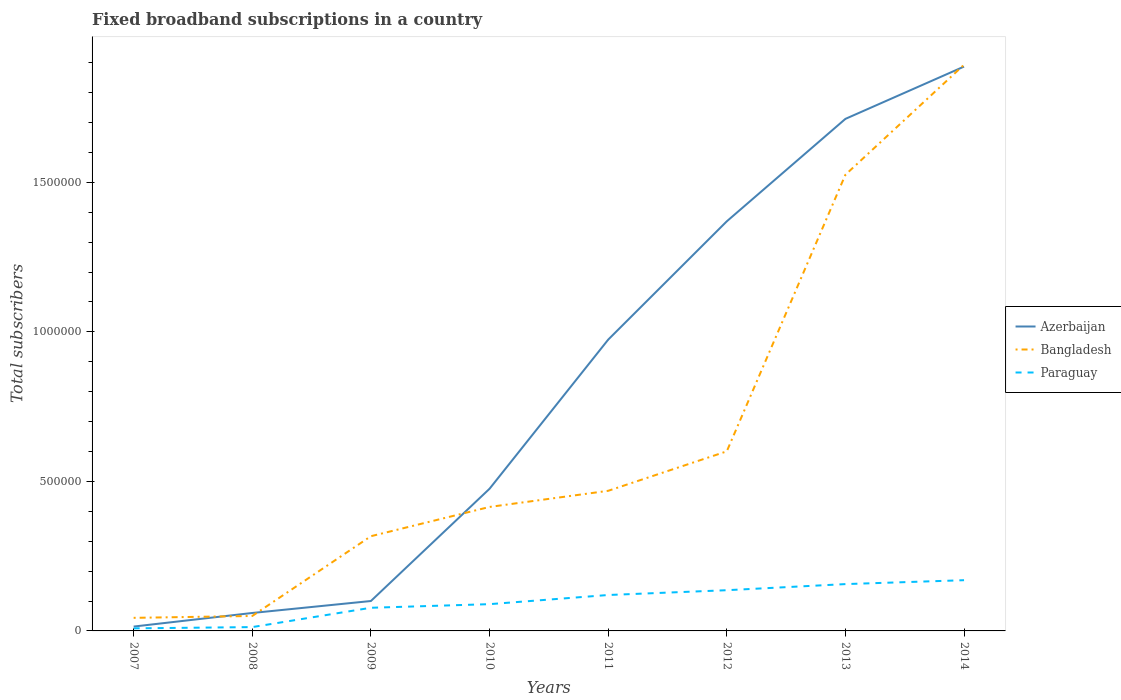How many different coloured lines are there?
Provide a succinct answer. 3. Does the line corresponding to Bangladesh intersect with the line corresponding to Azerbaijan?
Offer a terse response. Yes. Across all years, what is the maximum number of broadband subscriptions in Azerbaijan?
Make the answer very short. 1.46e+04. In which year was the number of broadband subscriptions in Paraguay maximum?
Keep it short and to the point. 2007. What is the total number of broadband subscriptions in Bangladesh in the graph?
Offer a terse response. -1.58e+06. What is the difference between the highest and the second highest number of broadband subscriptions in Azerbaijan?
Your response must be concise. 1.87e+06. What is the difference between the highest and the lowest number of broadband subscriptions in Paraguay?
Make the answer very short. 4. How many lines are there?
Your answer should be very brief. 3. What is the difference between two consecutive major ticks on the Y-axis?
Keep it short and to the point. 5.00e+05. Does the graph contain grids?
Make the answer very short. No. How are the legend labels stacked?
Your answer should be very brief. Vertical. What is the title of the graph?
Your answer should be compact. Fixed broadband subscriptions in a country. Does "Mongolia" appear as one of the legend labels in the graph?
Offer a very short reply. No. What is the label or title of the X-axis?
Your response must be concise. Years. What is the label or title of the Y-axis?
Provide a succinct answer. Total subscribers. What is the Total subscribers in Azerbaijan in 2007?
Offer a terse response. 1.46e+04. What is the Total subscribers of Bangladesh in 2007?
Your response must be concise. 4.37e+04. What is the Total subscribers of Paraguay in 2007?
Ensure brevity in your answer.  8600. What is the Total subscribers of Paraguay in 2008?
Provide a succinct answer. 1.28e+04. What is the Total subscribers of Bangladesh in 2009?
Offer a very short reply. 3.17e+05. What is the Total subscribers in Paraguay in 2009?
Provide a succinct answer. 7.74e+04. What is the Total subscribers of Azerbaijan in 2010?
Your answer should be very brief. 4.75e+05. What is the Total subscribers in Bangladesh in 2010?
Give a very brief answer. 4.15e+05. What is the Total subscribers in Paraguay in 2010?
Give a very brief answer. 8.95e+04. What is the Total subscribers in Azerbaijan in 2011?
Give a very brief answer. 9.74e+05. What is the Total subscribers of Bangladesh in 2011?
Keep it short and to the point. 4.68e+05. What is the Total subscribers in Paraguay in 2011?
Offer a terse response. 1.20e+05. What is the Total subscribers of Azerbaijan in 2012?
Offer a terse response. 1.37e+06. What is the Total subscribers of Bangladesh in 2012?
Make the answer very short. 6.00e+05. What is the Total subscribers in Paraguay in 2012?
Your response must be concise. 1.36e+05. What is the Total subscribers of Azerbaijan in 2013?
Your answer should be compact. 1.71e+06. What is the Total subscribers in Bangladesh in 2013?
Keep it short and to the point. 1.53e+06. What is the Total subscribers of Paraguay in 2013?
Your answer should be compact. 1.57e+05. What is the Total subscribers in Azerbaijan in 2014?
Keep it short and to the point. 1.89e+06. What is the Total subscribers in Bangladesh in 2014?
Provide a short and direct response. 1.89e+06. What is the Total subscribers in Paraguay in 2014?
Your answer should be compact. 1.70e+05. Across all years, what is the maximum Total subscribers in Azerbaijan?
Keep it short and to the point. 1.89e+06. Across all years, what is the maximum Total subscribers of Bangladesh?
Your answer should be compact. 1.89e+06. Across all years, what is the maximum Total subscribers in Paraguay?
Provide a short and direct response. 1.70e+05. Across all years, what is the minimum Total subscribers of Azerbaijan?
Offer a very short reply. 1.46e+04. Across all years, what is the minimum Total subscribers in Bangladesh?
Make the answer very short. 4.37e+04. Across all years, what is the minimum Total subscribers in Paraguay?
Your answer should be very brief. 8600. What is the total Total subscribers of Azerbaijan in the graph?
Ensure brevity in your answer.  6.59e+06. What is the total Total subscribers in Bangladesh in the graph?
Make the answer very short. 5.31e+06. What is the total Total subscribers in Paraguay in the graph?
Your answer should be compact. 7.71e+05. What is the difference between the Total subscribers of Azerbaijan in 2007 and that in 2008?
Provide a short and direct response. -4.54e+04. What is the difference between the Total subscribers in Bangladesh in 2007 and that in 2008?
Keep it short and to the point. -6290. What is the difference between the Total subscribers in Paraguay in 2007 and that in 2008?
Keep it short and to the point. -4200. What is the difference between the Total subscribers of Azerbaijan in 2007 and that in 2009?
Provide a short and direct response. -8.54e+04. What is the difference between the Total subscribers of Bangladesh in 2007 and that in 2009?
Your response must be concise. -2.73e+05. What is the difference between the Total subscribers in Paraguay in 2007 and that in 2009?
Provide a short and direct response. -6.88e+04. What is the difference between the Total subscribers of Azerbaijan in 2007 and that in 2010?
Give a very brief answer. -4.61e+05. What is the difference between the Total subscribers of Bangladesh in 2007 and that in 2010?
Give a very brief answer. -3.71e+05. What is the difference between the Total subscribers in Paraguay in 2007 and that in 2010?
Make the answer very short. -8.09e+04. What is the difference between the Total subscribers in Azerbaijan in 2007 and that in 2011?
Offer a very short reply. -9.59e+05. What is the difference between the Total subscribers of Bangladesh in 2007 and that in 2011?
Ensure brevity in your answer.  -4.25e+05. What is the difference between the Total subscribers in Paraguay in 2007 and that in 2011?
Provide a short and direct response. -1.12e+05. What is the difference between the Total subscribers of Azerbaijan in 2007 and that in 2012?
Ensure brevity in your answer.  -1.35e+06. What is the difference between the Total subscribers of Bangladesh in 2007 and that in 2012?
Provide a short and direct response. -5.57e+05. What is the difference between the Total subscribers of Paraguay in 2007 and that in 2012?
Provide a succinct answer. -1.28e+05. What is the difference between the Total subscribers in Azerbaijan in 2007 and that in 2013?
Your answer should be compact. -1.70e+06. What is the difference between the Total subscribers in Bangladesh in 2007 and that in 2013?
Make the answer very short. -1.48e+06. What is the difference between the Total subscribers of Paraguay in 2007 and that in 2013?
Provide a succinct answer. -1.48e+05. What is the difference between the Total subscribers in Azerbaijan in 2007 and that in 2014?
Provide a succinct answer. -1.87e+06. What is the difference between the Total subscribers in Bangladesh in 2007 and that in 2014?
Keep it short and to the point. -1.85e+06. What is the difference between the Total subscribers in Paraguay in 2007 and that in 2014?
Offer a very short reply. -1.61e+05. What is the difference between the Total subscribers in Azerbaijan in 2008 and that in 2009?
Your answer should be compact. -4.00e+04. What is the difference between the Total subscribers of Bangladesh in 2008 and that in 2009?
Provide a short and direct response. -2.67e+05. What is the difference between the Total subscribers in Paraguay in 2008 and that in 2009?
Offer a very short reply. -6.46e+04. What is the difference between the Total subscribers of Azerbaijan in 2008 and that in 2010?
Provide a succinct answer. -4.15e+05. What is the difference between the Total subscribers of Bangladesh in 2008 and that in 2010?
Provide a short and direct response. -3.65e+05. What is the difference between the Total subscribers in Paraguay in 2008 and that in 2010?
Ensure brevity in your answer.  -7.67e+04. What is the difference between the Total subscribers of Azerbaijan in 2008 and that in 2011?
Offer a very short reply. -9.14e+05. What is the difference between the Total subscribers in Bangladesh in 2008 and that in 2011?
Offer a terse response. -4.18e+05. What is the difference between the Total subscribers of Paraguay in 2008 and that in 2011?
Provide a short and direct response. -1.07e+05. What is the difference between the Total subscribers in Azerbaijan in 2008 and that in 2012?
Give a very brief answer. -1.31e+06. What is the difference between the Total subscribers of Bangladesh in 2008 and that in 2012?
Offer a very short reply. -5.50e+05. What is the difference between the Total subscribers of Paraguay in 2008 and that in 2012?
Make the answer very short. -1.23e+05. What is the difference between the Total subscribers of Azerbaijan in 2008 and that in 2013?
Provide a short and direct response. -1.65e+06. What is the difference between the Total subscribers of Bangladesh in 2008 and that in 2013?
Give a very brief answer. -1.48e+06. What is the difference between the Total subscribers in Paraguay in 2008 and that in 2013?
Offer a terse response. -1.44e+05. What is the difference between the Total subscribers of Azerbaijan in 2008 and that in 2014?
Make the answer very short. -1.83e+06. What is the difference between the Total subscribers of Bangladesh in 2008 and that in 2014?
Provide a succinct answer. -1.84e+06. What is the difference between the Total subscribers of Paraguay in 2008 and that in 2014?
Keep it short and to the point. -1.57e+05. What is the difference between the Total subscribers of Azerbaijan in 2009 and that in 2010?
Your answer should be compact. -3.75e+05. What is the difference between the Total subscribers in Bangladesh in 2009 and that in 2010?
Your answer should be compact. -9.79e+04. What is the difference between the Total subscribers of Paraguay in 2009 and that in 2010?
Give a very brief answer. -1.21e+04. What is the difference between the Total subscribers of Azerbaijan in 2009 and that in 2011?
Make the answer very short. -8.74e+05. What is the difference between the Total subscribers in Bangladesh in 2009 and that in 2011?
Keep it short and to the point. -1.52e+05. What is the difference between the Total subscribers in Paraguay in 2009 and that in 2011?
Give a very brief answer. -4.27e+04. What is the difference between the Total subscribers in Azerbaijan in 2009 and that in 2012?
Your answer should be compact. -1.27e+06. What is the difference between the Total subscribers in Bangladesh in 2009 and that in 2012?
Your response must be concise. -2.84e+05. What is the difference between the Total subscribers in Paraguay in 2009 and that in 2012?
Your answer should be very brief. -5.87e+04. What is the difference between the Total subscribers in Azerbaijan in 2009 and that in 2013?
Offer a very short reply. -1.61e+06. What is the difference between the Total subscribers in Bangladesh in 2009 and that in 2013?
Offer a terse response. -1.21e+06. What is the difference between the Total subscribers of Paraguay in 2009 and that in 2013?
Offer a terse response. -7.91e+04. What is the difference between the Total subscribers of Azerbaijan in 2009 and that in 2014?
Your answer should be very brief. -1.79e+06. What is the difference between the Total subscribers in Bangladesh in 2009 and that in 2014?
Your answer should be very brief. -1.58e+06. What is the difference between the Total subscribers in Paraguay in 2009 and that in 2014?
Ensure brevity in your answer.  -9.22e+04. What is the difference between the Total subscribers in Azerbaijan in 2010 and that in 2011?
Give a very brief answer. -4.99e+05. What is the difference between the Total subscribers in Bangladesh in 2010 and that in 2011?
Keep it short and to the point. -5.39e+04. What is the difference between the Total subscribers in Paraguay in 2010 and that in 2011?
Your response must be concise. -3.06e+04. What is the difference between the Total subscribers of Azerbaijan in 2010 and that in 2012?
Your answer should be compact. -8.94e+05. What is the difference between the Total subscribers of Bangladesh in 2010 and that in 2012?
Ensure brevity in your answer.  -1.86e+05. What is the difference between the Total subscribers of Paraguay in 2010 and that in 2012?
Offer a very short reply. -4.67e+04. What is the difference between the Total subscribers of Azerbaijan in 2010 and that in 2013?
Give a very brief answer. -1.24e+06. What is the difference between the Total subscribers of Bangladesh in 2010 and that in 2013?
Provide a short and direct response. -1.11e+06. What is the difference between the Total subscribers of Paraguay in 2010 and that in 2013?
Provide a succinct answer. -6.71e+04. What is the difference between the Total subscribers of Azerbaijan in 2010 and that in 2014?
Offer a very short reply. -1.41e+06. What is the difference between the Total subscribers in Bangladesh in 2010 and that in 2014?
Provide a short and direct response. -1.48e+06. What is the difference between the Total subscribers of Paraguay in 2010 and that in 2014?
Ensure brevity in your answer.  -8.01e+04. What is the difference between the Total subscribers in Azerbaijan in 2011 and that in 2012?
Your answer should be compact. -3.96e+05. What is the difference between the Total subscribers of Bangladesh in 2011 and that in 2012?
Offer a very short reply. -1.32e+05. What is the difference between the Total subscribers of Paraguay in 2011 and that in 2012?
Keep it short and to the point. -1.61e+04. What is the difference between the Total subscribers of Azerbaijan in 2011 and that in 2013?
Your answer should be very brief. -7.38e+05. What is the difference between the Total subscribers of Bangladesh in 2011 and that in 2013?
Make the answer very short. -1.06e+06. What is the difference between the Total subscribers in Paraguay in 2011 and that in 2013?
Provide a short and direct response. -3.65e+04. What is the difference between the Total subscribers of Azerbaijan in 2011 and that in 2014?
Your response must be concise. -9.13e+05. What is the difference between the Total subscribers in Bangladesh in 2011 and that in 2014?
Offer a very short reply. -1.42e+06. What is the difference between the Total subscribers of Paraguay in 2011 and that in 2014?
Ensure brevity in your answer.  -4.95e+04. What is the difference between the Total subscribers in Azerbaijan in 2012 and that in 2013?
Provide a succinct answer. -3.43e+05. What is the difference between the Total subscribers in Bangladesh in 2012 and that in 2013?
Your answer should be compact. -9.25e+05. What is the difference between the Total subscribers in Paraguay in 2012 and that in 2013?
Ensure brevity in your answer.  -2.04e+04. What is the difference between the Total subscribers of Azerbaijan in 2012 and that in 2014?
Your answer should be compact. -5.17e+05. What is the difference between the Total subscribers of Bangladesh in 2012 and that in 2014?
Ensure brevity in your answer.  -1.29e+06. What is the difference between the Total subscribers in Paraguay in 2012 and that in 2014?
Keep it short and to the point. -3.35e+04. What is the difference between the Total subscribers in Azerbaijan in 2013 and that in 2014?
Your answer should be very brief. -1.75e+05. What is the difference between the Total subscribers of Bangladesh in 2013 and that in 2014?
Your answer should be very brief. -3.68e+05. What is the difference between the Total subscribers in Paraguay in 2013 and that in 2014?
Your answer should be very brief. -1.30e+04. What is the difference between the Total subscribers in Azerbaijan in 2007 and the Total subscribers in Bangladesh in 2008?
Give a very brief answer. -3.54e+04. What is the difference between the Total subscribers of Azerbaijan in 2007 and the Total subscribers of Paraguay in 2008?
Keep it short and to the point. 1800. What is the difference between the Total subscribers in Bangladesh in 2007 and the Total subscribers in Paraguay in 2008?
Give a very brief answer. 3.09e+04. What is the difference between the Total subscribers in Azerbaijan in 2007 and the Total subscribers in Bangladesh in 2009?
Keep it short and to the point. -3.02e+05. What is the difference between the Total subscribers in Azerbaijan in 2007 and the Total subscribers in Paraguay in 2009?
Ensure brevity in your answer.  -6.28e+04. What is the difference between the Total subscribers in Bangladesh in 2007 and the Total subscribers in Paraguay in 2009?
Keep it short and to the point. -3.37e+04. What is the difference between the Total subscribers of Azerbaijan in 2007 and the Total subscribers of Bangladesh in 2010?
Keep it short and to the point. -4.00e+05. What is the difference between the Total subscribers in Azerbaijan in 2007 and the Total subscribers in Paraguay in 2010?
Provide a succinct answer. -7.49e+04. What is the difference between the Total subscribers in Bangladesh in 2007 and the Total subscribers in Paraguay in 2010?
Provide a succinct answer. -4.58e+04. What is the difference between the Total subscribers of Azerbaijan in 2007 and the Total subscribers of Bangladesh in 2011?
Your response must be concise. -4.54e+05. What is the difference between the Total subscribers in Azerbaijan in 2007 and the Total subscribers in Paraguay in 2011?
Make the answer very short. -1.06e+05. What is the difference between the Total subscribers of Bangladesh in 2007 and the Total subscribers of Paraguay in 2011?
Keep it short and to the point. -7.64e+04. What is the difference between the Total subscribers of Azerbaijan in 2007 and the Total subscribers of Bangladesh in 2012?
Offer a terse response. -5.86e+05. What is the difference between the Total subscribers in Azerbaijan in 2007 and the Total subscribers in Paraguay in 2012?
Your response must be concise. -1.22e+05. What is the difference between the Total subscribers of Bangladesh in 2007 and the Total subscribers of Paraguay in 2012?
Keep it short and to the point. -9.24e+04. What is the difference between the Total subscribers of Azerbaijan in 2007 and the Total subscribers of Bangladesh in 2013?
Your response must be concise. -1.51e+06. What is the difference between the Total subscribers in Azerbaijan in 2007 and the Total subscribers in Paraguay in 2013?
Your answer should be compact. -1.42e+05. What is the difference between the Total subscribers of Bangladesh in 2007 and the Total subscribers of Paraguay in 2013?
Provide a short and direct response. -1.13e+05. What is the difference between the Total subscribers in Azerbaijan in 2007 and the Total subscribers in Bangladesh in 2014?
Your answer should be compact. -1.88e+06. What is the difference between the Total subscribers of Azerbaijan in 2007 and the Total subscribers of Paraguay in 2014?
Keep it short and to the point. -1.55e+05. What is the difference between the Total subscribers in Bangladesh in 2007 and the Total subscribers in Paraguay in 2014?
Provide a short and direct response. -1.26e+05. What is the difference between the Total subscribers in Azerbaijan in 2008 and the Total subscribers in Bangladesh in 2009?
Keep it short and to the point. -2.57e+05. What is the difference between the Total subscribers of Azerbaijan in 2008 and the Total subscribers of Paraguay in 2009?
Make the answer very short. -1.74e+04. What is the difference between the Total subscribers of Bangladesh in 2008 and the Total subscribers of Paraguay in 2009?
Keep it short and to the point. -2.74e+04. What is the difference between the Total subscribers of Azerbaijan in 2008 and the Total subscribers of Bangladesh in 2010?
Your answer should be very brief. -3.55e+05. What is the difference between the Total subscribers in Azerbaijan in 2008 and the Total subscribers in Paraguay in 2010?
Offer a terse response. -2.95e+04. What is the difference between the Total subscribers in Bangladesh in 2008 and the Total subscribers in Paraguay in 2010?
Keep it short and to the point. -3.95e+04. What is the difference between the Total subscribers of Azerbaijan in 2008 and the Total subscribers of Bangladesh in 2011?
Your answer should be compact. -4.08e+05. What is the difference between the Total subscribers in Azerbaijan in 2008 and the Total subscribers in Paraguay in 2011?
Keep it short and to the point. -6.01e+04. What is the difference between the Total subscribers in Bangladesh in 2008 and the Total subscribers in Paraguay in 2011?
Offer a terse response. -7.01e+04. What is the difference between the Total subscribers in Azerbaijan in 2008 and the Total subscribers in Bangladesh in 2012?
Provide a short and direct response. -5.40e+05. What is the difference between the Total subscribers of Azerbaijan in 2008 and the Total subscribers of Paraguay in 2012?
Offer a terse response. -7.62e+04. What is the difference between the Total subscribers in Bangladesh in 2008 and the Total subscribers in Paraguay in 2012?
Offer a terse response. -8.62e+04. What is the difference between the Total subscribers in Azerbaijan in 2008 and the Total subscribers in Bangladesh in 2013?
Offer a terse response. -1.47e+06. What is the difference between the Total subscribers of Azerbaijan in 2008 and the Total subscribers of Paraguay in 2013?
Provide a short and direct response. -9.66e+04. What is the difference between the Total subscribers in Bangladesh in 2008 and the Total subscribers in Paraguay in 2013?
Make the answer very short. -1.07e+05. What is the difference between the Total subscribers in Azerbaijan in 2008 and the Total subscribers in Bangladesh in 2014?
Provide a succinct answer. -1.83e+06. What is the difference between the Total subscribers in Azerbaijan in 2008 and the Total subscribers in Paraguay in 2014?
Your answer should be very brief. -1.10e+05. What is the difference between the Total subscribers in Bangladesh in 2008 and the Total subscribers in Paraguay in 2014?
Your answer should be very brief. -1.20e+05. What is the difference between the Total subscribers of Azerbaijan in 2009 and the Total subscribers of Bangladesh in 2010?
Give a very brief answer. -3.15e+05. What is the difference between the Total subscribers in Azerbaijan in 2009 and the Total subscribers in Paraguay in 2010?
Your answer should be very brief. 1.05e+04. What is the difference between the Total subscribers of Bangladesh in 2009 and the Total subscribers of Paraguay in 2010?
Offer a terse response. 2.27e+05. What is the difference between the Total subscribers in Azerbaijan in 2009 and the Total subscribers in Bangladesh in 2011?
Give a very brief answer. -3.68e+05. What is the difference between the Total subscribers in Azerbaijan in 2009 and the Total subscribers in Paraguay in 2011?
Give a very brief answer. -2.01e+04. What is the difference between the Total subscribers of Bangladesh in 2009 and the Total subscribers of Paraguay in 2011?
Your answer should be compact. 1.97e+05. What is the difference between the Total subscribers of Azerbaijan in 2009 and the Total subscribers of Bangladesh in 2012?
Your answer should be compact. -5.00e+05. What is the difference between the Total subscribers in Azerbaijan in 2009 and the Total subscribers in Paraguay in 2012?
Your response must be concise. -3.62e+04. What is the difference between the Total subscribers in Bangladesh in 2009 and the Total subscribers in Paraguay in 2012?
Offer a terse response. 1.81e+05. What is the difference between the Total subscribers in Azerbaijan in 2009 and the Total subscribers in Bangladesh in 2013?
Your response must be concise. -1.43e+06. What is the difference between the Total subscribers in Azerbaijan in 2009 and the Total subscribers in Paraguay in 2013?
Give a very brief answer. -5.66e+04. What is the difference between the Total subscribers of Bangladesh in 2009 and the Total subscribers of Paraguay in 2013?
Your response must be concise. 1.60e+05. What is the difference between the Total subscribers in Azerbaijan in 2009 and the Total subscribers in Bangladesh in 2014?
Give a very brief answer. -1.79e+06. What is the difference between the Total subscribers of Azerbaijan in 2009 and the Total subscribers of Paraguay in 2014?
Keep it short and to the point. -6.96e+04. What is the difference between the Total subscribers in Bangladesh in 2009 and the Total subscribers in Paraguay in 2014?
Your answer should be very brief. 1.47e+05. What is the difference between the Total subscribers of Azerbaijan in 2010 and the Total subscribers of Bangladesh in 2011?
Offer a very short reply. 6795. What is the difference between the Total subscribers in Azerbaijan in 2010 and the Total subscribers in Paraguay in 2011?
Offer a very short reply. 3.55e+05. What is the difference between the Total subscribers of Bangladesh in 2010 and the Total subscribers of Paraguay in 2011?
Offer a very short reply. 2.94e+05. What is the difference between the Total subscribers in Azerbaijan in 2010 and the Total subscribers in Bangladesh in 2012?
Your answer should be compact. -1.25e+05. What is the difference between the Total subscribers in Azerbaijan in 2010 and the Total subscribers in Paraguay in 2012?
Your answer should be very brief. 3.39e+05. What is the difference between the Total subscribers in Bangladesh in 2010 and the Total subscribers in Paraguay in 2012?
Your answer should be compact. 2.78e+05. What is the difference between the Total subscribers of Azerbaijan in 2010 and the Total subscribers of Bangladesh in 2013?
Offer a very short reply. -1.05e+06. What is the difference between the Total subscribers in Azerbaijan in 2010 and the Total subscribers in Paraguay in 2013?
Ensure brevity in your answer.  3.19e+05. What is the difference between the Total subscribers in Bangladesh in 2010 and the Total subscribers in Paraguay in 2013?
Your answer should be very brief. 2.58e+05. What is the difference between the Total subscribers of Azerbaijan in 2010 and the Total subscribers of Bangladesh in 2014?
Your answer should be very brief. -1.42e+06. What is the difference between the Total subscribers of Azerbaijan in 2010 and the Total subscribers of Paraguay in 2014?
Keep it short and to the point. 3.06e+05. What is the difference between the Total subscribers of Bangladesh in 2010 and the Total subscribers of Paraguay in 2014?
Your answer should be very brief. 2.45e+05. What is the difference between the Total subscribers in Azerbaijan in 2011 and the Total subscribers in Bangladesh in 2012?
Make the answer very short. 3.73e+05. What is the difference between the Total subscribers of Azerbaijan in 2011 and the Total subscribers of Paraguay in 2012?
Make the answer very short. 8.38e+05. What is the difference between the Total subscribers in Bangladesh in 2011 and the Total subscribers in Paraguay in 2012?
Keep it short and to the point. 3.32e+05. What is the difference between the Total subscribers of Azerbaijan in 2011 and the Total subscribers of Bangladesh in 2013?
Your answer should be very brief. -5.51e+05. What is the difference between the Total subscribers in Azerbaijan in 2011 and the Total subscribers in Paraguay in 2013?
Your answer should be very brief. 8.17e+05. What is the difference between the Total subscribers of Bangladesh in 2011 and the Total subscribers of Paraguay in 2013?
Offer a terse response. 3.12e+05. What is the difference between the Total subscribers of Azerbaijan in 2011 and the Total subscribers of Bangladesh in 2014?
Offer a very short reply. -9.19e+05. What is the difference between the Total subscribers of Azerbaijan in 2011 and the Total subscribers of Paraguay in 2014?
Ensure brevity in your answer.  8.04e+05. What is the difference between the Total subscribers in Bangladesh in 2011 and the Total subscribers in Paraguay in 2014?
Offer a very short reply. 2.99e+05. What is the difference between the Total subscribers in Azerbaijan in 2012 and the Total subscribers in Bangladesh in 2013?
Keep it short and to the point. -1.56e+05. What is the difference between the Total subscribers in Azerbaijan in 2012 and the Total subscribers in Paraguay in 2013?
Your answer should be very brief. 1.21e+06. What is the difference between the Total subscribers in Bangladesh in 2012 and the Total subscribers in Paraguay in 2013?
Give a very brief answer. 4.44e+05. What is the difference between the Total subscribers of Azerbaijan in 2012 and the Total subscribers of Bangladesh in 2014?
Offer a terse response. -5.24e+05. What is the difference between the Total subscribers in Azerbaijan in 2012 and the Total subscribers in Paraguay in 2014?
Give a very brief answer. 1.20e+06. What is the difference between the Total subscribers of Bangladesh in 2012 and the Total subscribers of Paraguay in 2014?
Your response must be concise. 4.31e+05. What is the difference between the Total subscribers of Azerbaijan in 2013 and the Total subscribers of Bangladesh in 2014?
Your answer should be very brief. -1.81e+05. What is the difference between the Total subscribers of Azerbaijan in 2013 and the Total subscribers of Paraguay in 2014?
Offer a very short reply. 1.54e+06. What is the difference between the Total subscribers in Bangladesh in 2013 and the Total subscribers in Paraguay in 2014?
Provide a short and direct response. 1.36e+06. What is the average Total subscribers in Azerbaijan per year?
Your answer should be compact. 8.24e+05. What is the average Total subscribers of Bangladesh per year?
Give a very brief answer. 6.64e+05. What is the average Total subscribers in Paraguay per year?
Keep it short and to the point. 9.63e+04. In the year 2007, what is the difference between the Total subscribers in Azerbaijan and Total subscribers in Bangladesh?
Your answer should be very brief. -2.91e+04. In the year 2007, what is the difference between the Total subscribers in Azerbaijan and Total subscribers in Paraguay?
Your answer should be compact. 6000. In the year 2007, what is the difference between the Total subscribers in Bangladesh and Total subscribers in Paraguay?
Ensure brevity in your answer.  3.51e+04. In the year 2008, what is the difference between the Total subscribers of Azerbaijan and Total subscribers of Paraguay?
Make the answer very short. 4.72e+04. In the year 2008, what is the difference between the Total subscribers in Bangladesh and Total subscribers in Paraguay?
Ensure brevity in your answer.  3.72e+04. In the year 2009, what is the difference between the Total subscribers of Azerbaijan and Total subscribers of Bangladesh?
Provide a short and direct response. -2.17e+05. In the year 2009, what is the difference between the Total subscribers of Azerbaijan and Total subscribers of Paraguay?
Provide a short and direct response. 2.26e+04. In the year 2009, what is the difference between the Total subscribers in Bangladesh and Total subscribers in Paraguay?
Your answer should be compact. 2.39e+05. In the year 2010, what is the difference between the Total subscribers in Azerbaijan and Total subscribers in Bangladesh?
Keep it short and to the point. 6.07e+04. In the year 2010, what is the difference between the Total subscribers in Azerbaijan and Total subscribers in Paraguay?
Your answer should be compact. 3.86e+05. In the year 2010, what is the difference between the Total subscribers of Bangladesh and Total subscribers of Paraguay?
Give a very brief answer. 3.25e+05. In the year 2011, what is the difference between the Total subscribers of Azerbaijan and Total subscribers of Bangladesh?
Provide a short and direct response. 5.05e+05. In the year 2011, what is the difference between the Total subscribers of Azerbaijan and Total subscribers of Paraguay?
Ensure brevity in your answer.  8.54e+05. In the year 2011, what is the difference between the Total subscribers of Bangladesh and Total subscribers of Paraguay?
Ensure brevity in your answer.  3.48e+05. In the year 2012, what is the difference between the Total subscribers in Azerbaijan and Total subscribers in Bangladesh?
Offer a very short reply. 7.69e+05. In the year 2012, what is the difference between the Total subscribers in Azerbaijan and Total subscribers in Paraguay?
Provide a short and direct response. 1.23e+06. In the year 2012, what is the difference between the Total subscribers in Bangladesh and Total subscribers in Paraguay?
Provide a succinct answer. 4.64e+05. In the year 2013, what is the difference between the Total subscribers in Azerbaijan and Total subscribers in Bangladesh?
Your answer should be compact. 1.87e+05. In the year 2013, what is the difference between the Total subscribers in Azerbaijan and Total subscribers in Paraguay?
Offer a very short reply. 1.56e+06. In the year 2013, what is the difference between the Total subscribers of Bangladesh and Total subscribers of Paraguay?
Your response must be concise. 1.37e+06. In the year 2014, what is the difference between the Total subscribers of Azerbaijan and Total subscribers of Bangladesh?
Provide a succinct answer. -6101. In the year 2014, what is the difference between the Total subscribers in Azerbaijan and Total subscribers in Paraguay?
Offer a very short reply. 1.72e+06. In the year 2014, what is the difference between the Total subscribers in Bangladesh and Total subscribers in Paraguay?
Offer a very short reply. 1.72e+06. What is the ratio of the Total subscribers in Azerbaijan in 2007 to that in 2008?
Provide a short and direct response. 0.24. What is the ratio of the Total subscribers of Bangladesh in 2007 to that in 2008?
Offer a terse response. 0.87. What is the ratio of the Total subscribers in Paraguay in 2007 to that in 2008?
Provide a short and direct response. 0.67. What is the ratio of the Total subscribers of Azerbaijan in 2007 to that in 2009?
Your answer should be compact. 0.15. What is the ratio of the Total subscribers of Bangladesh in 2007 to that in 2009?
Provide a succinct answer. 0.14. What is the ratio of the Total subscribers in Paraguay in 2007 to that in 2009?
Your answer should be very brief. 0.11. What is the ratio of the Total subscribers in Azerbaijan in 2007 to that in 2010?
Ensure brevity in your answer.  0.03. What is the ratio of the Total subscribers in Bangladesh in 2007 to that in 2010?
Give a very brief answer. 0.11. What is the ratio of the Total subscribers of Paraguay in 2007 to that in 2010?
Your answer should be compact. 0.1. What is the ratio of the Total subscribers of Azerbaijan in 2007 to that in 2011?
Provide a succinct answer. 0.01. What is the ratio of the Total subscribers in Bangladesh in 2007 to that in 2011?
Make the answer very short. 0.09. What is the ratio of the Total subscribers in Paraguay in 2007 to that in 2011?
Give a very brief answer. 0.07. What is the ratio of the Total subscribers of Azerbaijan in 2007 to that in 2012?
Keep it short and to the point. 0.01. What is the ratio of the Total subscribers in Bangladesh in 2007 to that in 2012?
Your response must be concise. 0.07. What is the ratio of the Total subscribers in Paraguay in 2007 to that in 2012?
Ensure brevity in your answer.  0.06. What is the ratio of the Total subscribers in Azerbaijan in 2007 to that in 2013?
Keep it short and to the point. 0.01. What is the ratio of the Total subscribers in Bangladesh in 2007 to that in 2013?
Offer a very short reply. 0.03. What is the ratio of the Total subscribers of Paraguay in 2007 to that in 2013?
Offer a terse response. 0.05. What is the ratio of the Total subscribers of Azerbaijan in 2007 to that in 2014?
Your answer should be compact. 0.01. What is the ratio of the Total subscribers in Bangladesh in 2007 to that in 2014?
Your answer should be very brief. 0.02. What is the ratio of the Total subscribers of Paraguay in 2007 to that in 2014?
Your answer should be very brief. 0.05. What is the ratio of the Total subscribers of Azerbaijan in 2008 to that in 2009?
Provide a short and direct response. 0.6. What is the ratio of the Total subscribers of Bangladesh in 2008 to that in 2009?
Provide a succinct answer. 0.16. What is the ratio of the Total subscribers in Paraguay in 2008 to that in 2009?
Ensure brevity in your answer.  0.17. What is the ratio of the Total subscribers in Azerbaijan in 2008 to that in 2010?
Offer a very short reply. 0.13. What is the ratio of the Total subscribers of Bangladesh in 2008 to that in 2010?
Your answer should be very brief. 0.12. What is the ratio of the Total subscribers of Paraguay in 2008 to that in 2010?
Ensure brevity in your answer.  0.14. What is the ratio of the Total subscribers of Azerbaijan in 2008 to that in 2011?
Make the answer very short. 0.06. What is the ratio of the Total subscribers of Bangladesh in 2008 to that in 2011?
Your answer should be compact. 0.11. What is the ratio of the Total subscribers in Paraguay in 2008 to that in 2011?
Ensure brevity in your answer.  0.11. What is the ratio of the Total subscribers of Azerbaijan in 2008 to that in 2012?
Keep it short and to the point. 0.04. What is the ratio of the Total subscribers of Bangladesh in 2008 to that in 2012?
Offer a terse response. 0.08. What is the ratio of the Total subscribers in Paraguay in 2008 to that in 2012?
Your answer should be compact. 0.09. What is the ratio of the Total subscribers in Azerbaijan in 2008 to that in 2013?
Keep it short and to the point. 0.04. What is the ratio of the Total subscribers in Bangladesh in 2008 to that in 2013?
Provide a short and direct response. 0.03. What is the ratio of the Total subscribers of Paraguay in 2008 to that in 2013?
Ensure brevity in your answer.  0.08. What is the ratio of the Total subscribers of Azerbaijan in 2008 to that in 2014?
Keep it short and to the point. 0.03. What is the ratio of the Total subscribers in Bangladesh in 2008 to that in 2014?
Offer a very short reply. 0.03. What is the ratio of the Total subscribers in Paraguay in 2008 to that in 2014?
Offer a very short reply. 0.08. What is the ratio of the Total subscribers in Azerbaijan in 2009 to that in 2010?
Offer a very short reply. 0.21. What is the ratio of the Total subscribers of Bangladesh in 2009 to that in 2010?
Ensure brevity in your answer.  0.76. What is the ratio of the Total subscribers in Paraguay in 2009 to that in 2010?
Offer a very short reply. 0.87. What is the ratio of the Total subscribers of Azerbaijan in 2009 to that in 2011?
Offer a very short reply. 0.1. What is the ratio of the Total subscribers of Bangladesh in 2009 to that in 2011?
Keep it short and to the point. 0.68. What is the ratio of the Total subscribers in Paraguay in 2009 to that in 2011?
Make the answer very short. 0.64. What is the ratio of the Total subscribers in Azerbaijan in 2009 to that in 2012?
Your answer should be compact. 0.07. What is the ratio of the Total subscribers in Bangladesh in 2009 to that in 2012?
Ensure brevity in your answer.  0.53. What is the ratio of the Total subscribers in Paraguay in 2009 to that in 2012?
Keep it short and to the point. 0.57. What is the ratio of the Total subscribers in Azerbaijan in 2009 to that in 2013?
Your response must be concise. 0.06. What is the ratio of the Total subscribers of Bangladesh in 2009 to that in 2013?
Offer a terse response. 0.21. What is the ratio of the Total subscribers of Paraguay in 2009 to that in 2013?
Offer a terse response. 0.49. What is the ratio of the Total subscribers in Azerbaijan in 2009 to that in 2014?
Provide a succinct answer. 0.05. What is the ratio of the Total subscribers in Bangladesh in 2009 to that in 2014?
Provide a succinct answer. 0.17. What is the ratio of the Total subscribers of Paraguay in 2009 to that in 2014?
Provide a short and direct response. 0.46. What is the ratio of the Total subscribers of Azerbaijan in 2010 to that in 2011?
Your answer should be compact. 0.49. What is the ratio of the Total subscribers of Bangladesh in 2010 to that in 2011?
Make the answer very short. 0.88. What is the ratio of the Total subscribers in Paraguay in 2010 to that in 2011?
Offer a very short reply. 0.75. What is the ratio of the Total subscribers in Azerbaijan in 2010 to that in 2012?
Ensure brevity in your answer.  0.35. What is the ratio of the Total subscribers in Bangladesh in 2010 to that in 2012?
Ensure brevity in your answer.  0.69. What is the ratio of the Total subscribers in Paraguay in 2010 to that in 2012?
Keep it short and to the point. 0.66. What is the ratio of the Total subscribers in Azerbaijan in 2010 to that in 2013?
Ensure brevity in your answer.  0.28. What is the ratio of the Total subscribers of Bangladesh in 2010 to that in 2013?
Your response must be concise. 0.27. What is the ratio of the Total subscribers of Paraguay in 2010 to that in 2013?
Your answer should be very brief. 0.57. What is the ratio of the Total subscribers of Azerbaijan in 2010 to that in 2014?
Offer a terse response. 0.25. What is the ratio of the Total subscribers of Bangladesh in 2010 to that in 2014?
Keep it short and to the point. 0.22. What is the ratio of the Total subscribers of Paraguay in 2010 to that in 2014?
Ensure brevity in your answer.  0.53. What is the ratio of the Total subscribers of Azerbaijan in 2011 to that in 2012?
Your response must be concise. 0.71. What is the ratio of the Total subscribers of Bangladesh in 2011 to that in 2012?
Your answer should be compact. 0.78. What is the ratio of the Total subscribers of Paraguay in 2011 to that in 2012?
Provide a succinct answer. 0.88. What is the ratio of the Total subscribers of Azerbaijan in 2011 to that in 2013?
Your response must be concise. 0.57. What is the ratio of the Total subscribers in Bangladesh in 2011 to that in 2013?
Your response must be concise. 0.31. What is the ratio of the Total subscribers of Paraguay in 2011 to that in 2013?
Ensure brevity in your answer.  0.77. What is the ratio of the Total subscribers in Azerbaijan in 2011 to that in 2014?
Offer a terse response. 0.52. What is the ratio of the Total subscribers in Bangladesh in 2011 to that in 2014?
Your answer should be very brief. 0.25. What is the ratio of the Total subscribers of Paraguay in 2011 to that in 2014?
Ensure brevity in your answer.  0.71. What is the ratio of the Total subscribers of Azerbaijan in 2012 to that in 2013?
Provide a short and direct response. 0.8. What is the ratio of the Total subscribers in Bangladesh in 2012 to that in 2013?
Give a very brief answer. 0.39. What is the ratio of the Total subscribers of Paraguay in 2012 to that in 2013?
Your answer should be compact. 0.87. What is the ratio of the Total subscribers of Azerbaijan in 2012 to that in 2014?
Your answer should be very brief. 0.73. What is the ratio of the Total subscribers of Bangladesh in 2012 to that in 2014?
Provide a succinct answer. 0.32. What is the ratio of the Total subscribers of Paraguay in 2012 to that in 2014?
Your answer should be compact. 0.8. What is the ratio of the Total subscribers of Azerbaijan in 2013 to that in 2014?
Provide a succinct answer. 0.91. What is the ratio of the Total subscribers in Bangladesh in 2013 to that in 2014?
Provide a succinct answer. 0.81. What is the ratio of the Total subscribers in Paraguay in 2013 to that in 2014?
Keep it short and to the point. 0.92. What is the difference between the highest and the second highest Total subscribers of Azerbaijan?
Your answer should be compact. 1.75e+05. What is the difference between the highest and the second highest Total subscribers of Bangladesh?
Ensure brevity in your answer.  3.68e+05. What is the difference between the highest and the second highest Total subscribers of Paraguay?
Provide a short and direct response. 1.30e+04. What is the difference between the highest and the lowest Total subscribers of Azerbaijan?
Keep it short and to the point. 1.87e+06. What is the difference between the highest and the lowest Total subscribers in Bangladesh?
Ensure brevity in your answer.  1.85e+06. What is the difference between the highest and the lowest Total subscribers in Paraguay?
Your answer should be compact. 1.61e+05. 